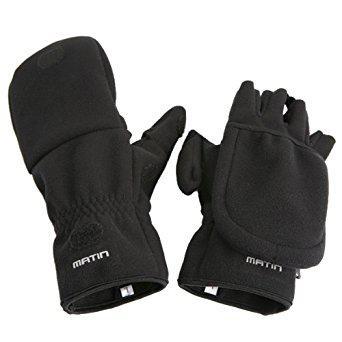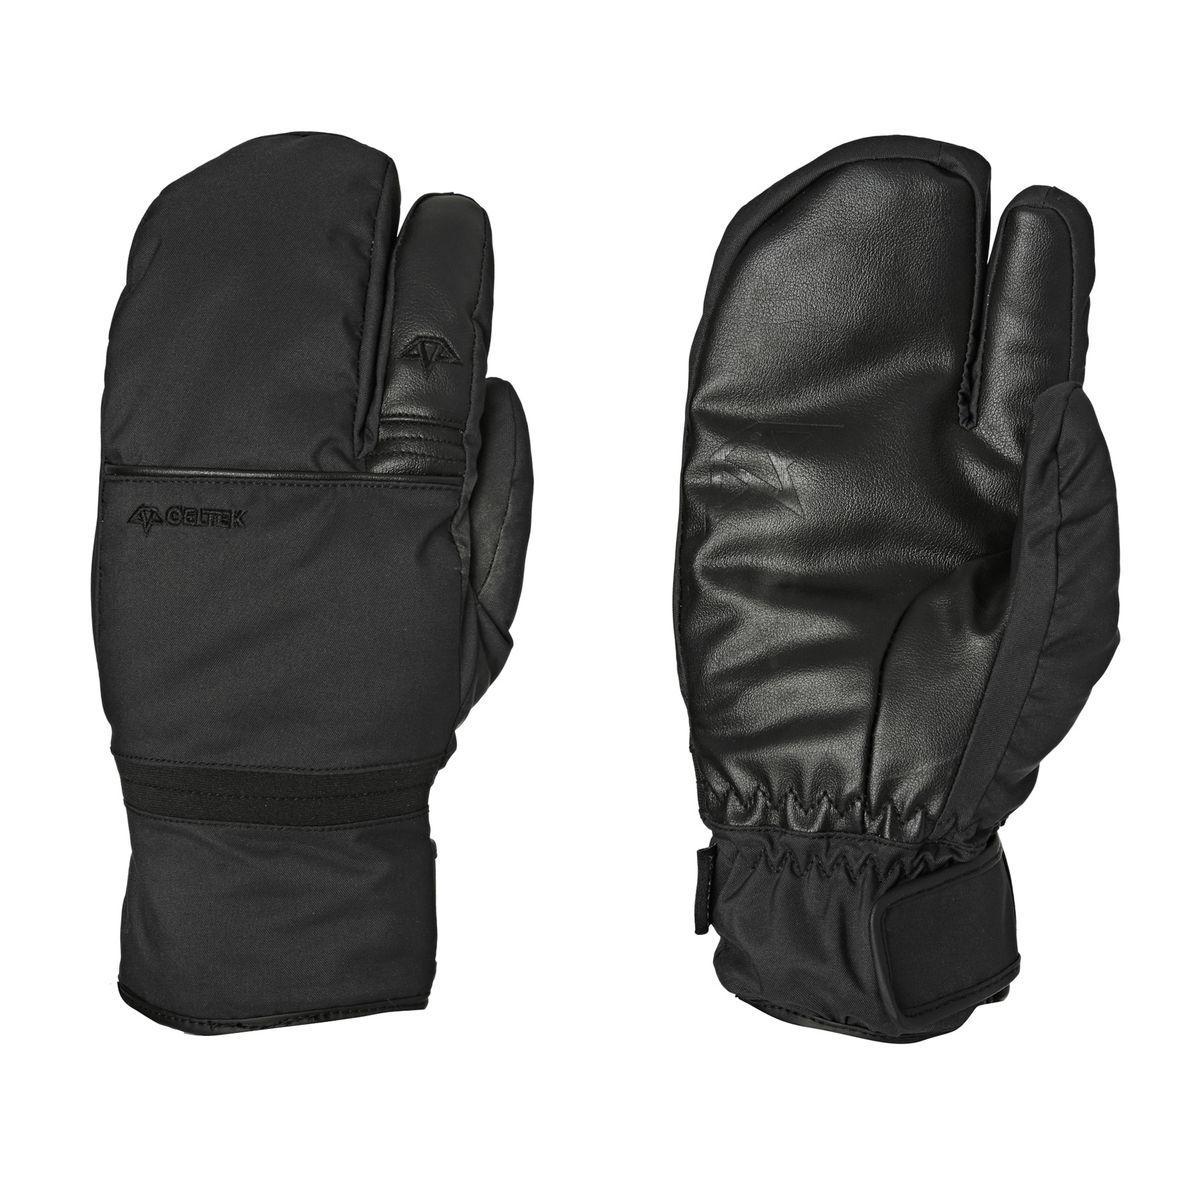The first image is the image on the left, the second image is the image on the right. For the images displayed, is the sentence "There are two gloves without fingers." factually correct? Answer yes or no. No. The first image is the image on the left, the second image is the image on the right. Analyze the images presented: Is the assertion "Each pair of mittens includes at least one with a rounded covered top, and no mitten has four full-length fingers with tips." valid? Answer yes or no. Yes. 